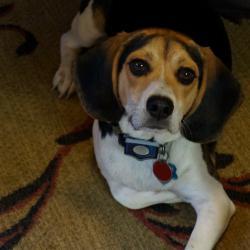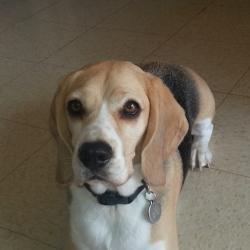The first image is the image on the left, the second image is the image on the right. For the images shown, is this caption "The right image contains exactly two dogs." true? Answer yes or no. No. The first image is the image on the left, the second image is the image on the right. Assess this claim about the two images: "One image contains twice as many beagles as the other, and the combined images total three dogs.". Correct or not? Answer yes or no. No. 